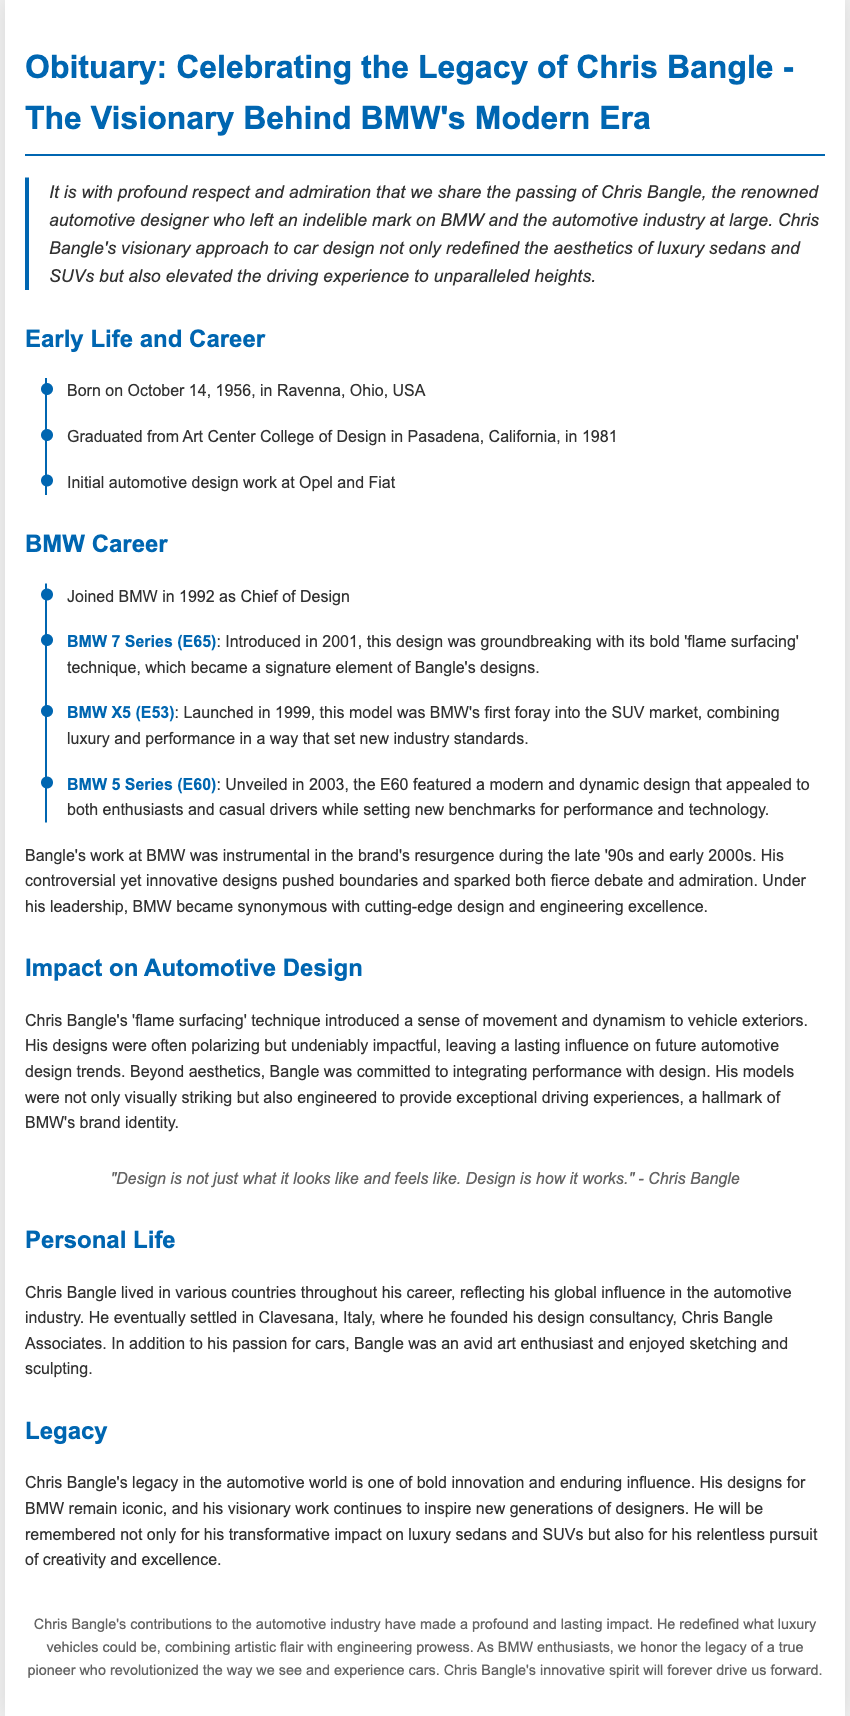What is the name of the designer? The obituary is centered around Chris Bangle, a prominent automotive designer known for his work at BMW.
Answer: Chris Bangle When was Chris Bangle born? The document states that Chris Bangle was born on October 14, 1956, in Ravenna, Ohio, USA.
Answer: October 14, 1956 What was the groundbreaking technique introduced in the BMW 7 Series (E65)? The design of the BMW 7 Series (E65) was characterized by Bangle's bold 'flame surfacing' technique, a signature element of his designs.
Answer: Flame surfacing Which model was BMW's first SUV? The obituary mentions the launch of the BMW X5 (E53) in 1999 as BMW's initial venture into the SUV market.
Answer: BMW X5 (E53) What was Chris Bangle's educational background? The document indicates that he graduated from Art Center College of Design in Pasadena, California, in 1981.
Answer: Art Center College of Design What significant influence did Chris Bangle have on automotive design? Bangle's impact on automotive design included the introduction of the 'flame surfacing' technique and a focus on integrating performance with aesthetics.
Answer: Lasting influence Where did Chris Bangle found his design consultancy? The obituary notes that he eventually settled in Clavesana, Italy, to establish his design consultancy, Chris Bangle Associates.
Answer: Clavesana, Italy What did Bangle believe design encompasses beyond appearance? The quote attributed to Chris Bangle clarifies that design is about how things work, not just their looks and feels.
Answer: How it works What type of cars did Bangle notably influence? The document highlights that Bangle revolutionized the aesthetics and performance of luxury sedans and SUVs.
Answer: Luxury sedans and SUVs 